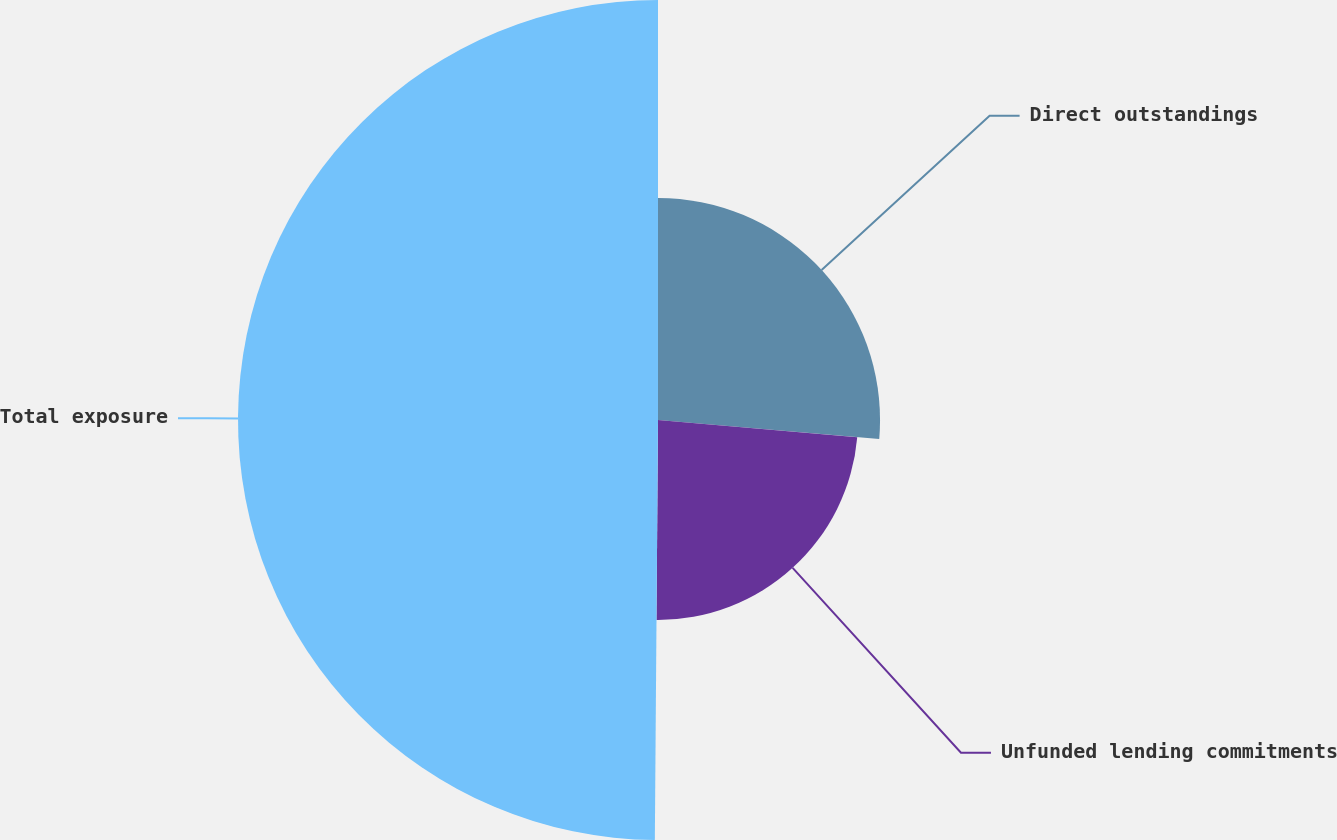Convert chart to OTSL. <chart><loc_0><loc_0><loc_500><loc_500><pie_chart><fcel>Direct outstandings<fcel>Unfunded lending commitments<fcel>Total exposure<nl><fcel>26.37%<fcel>23.75%<fcel>49.88%<nl></chart> 